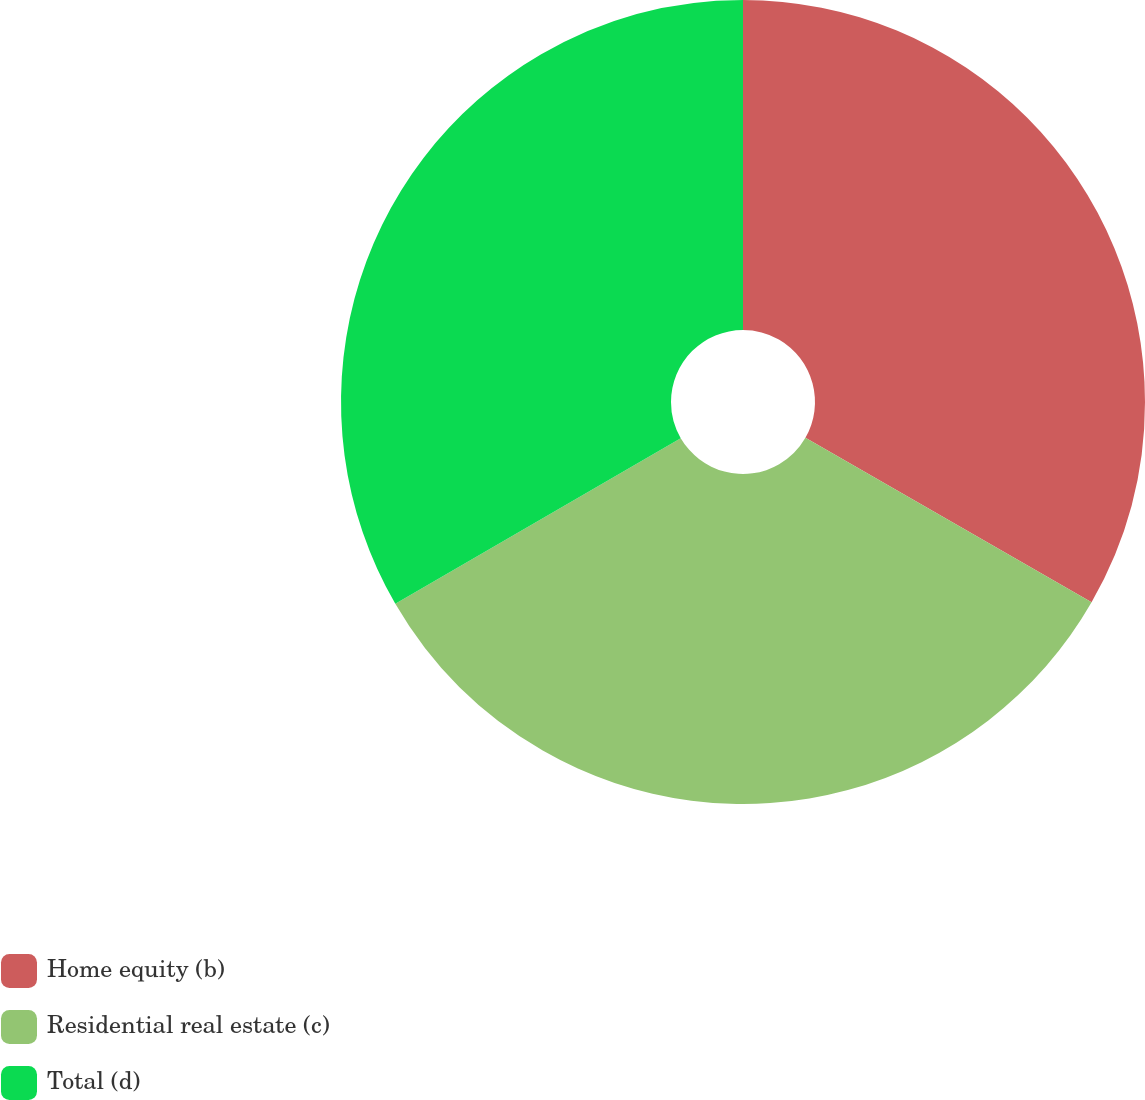Convert chart to OTSL. <chart><loc_0><loc_0><loc_500><loc_500><pie_chart><fcel>Home equity (b)<fcel>Residential real estate (c)<fcel>Total (d)<nl><fcel>33.3%<fcel>33.33%<fcel>33.37%<nl></chart> 